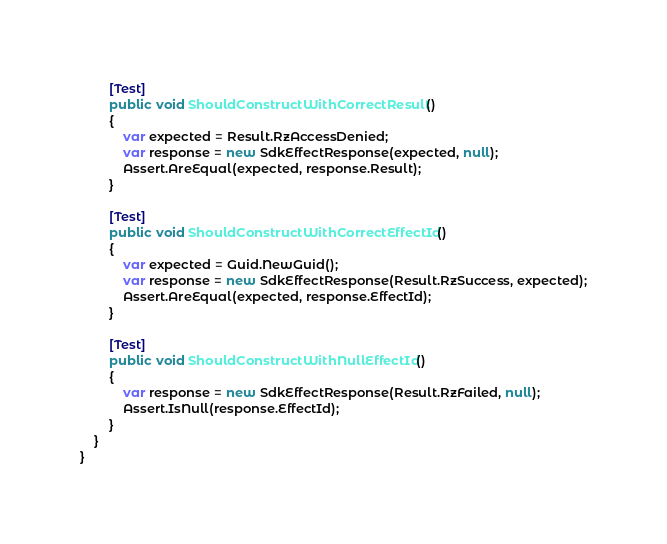Convert code to text. <code><loc_0><loc_0><loc_500><loc_500><_C#_>        [Test]
        public void ShouldConstructWithCorrectResult()
        {
            var expected = Result.RzAccessDenied;
            var response = new SdkEffectResponse(expected, null);
            Assert.AreEqual(expected, response.Result);
        }

        [Test]
        public void ShouldConstructWithCorrectEffectId()
        {
            var expected = Guid.NewGuid();
            var response = new SdkEffectResponse(Result.RzSuccess, expected);
            Assert.AreEqual(expected, response.EffectId);
        }

        [Test]
        public void ShouldConstructWithNullEffectId()
        {
            var response = new SdkEffectResponse(Result.RzFailed, null);
            Assert.IsNull(response.EffectId);
        }
    }
}
</code> 